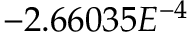<formula> <loc_0><loc_0><loc_500><loc_500>- 2 . 6 6 0 3 5 E ^ { - 4 }</formula> 